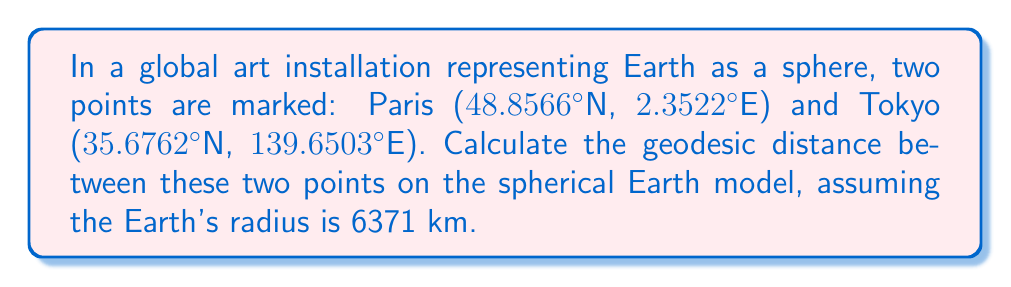Help me with this question. To calculate the geodesic distance between two points on a sphere, we use the Haversine formula:

1. Convert the latitudes and longitudes from degrees to radians:
   $$\phi_1 = 48.8566° \cdot \frac{\pi}{180} = 0.8527 \text{ rad}$$
   $$\lambda_1 = 2.3522° \cdot \frac{\pi}{180} = 0.0411 \text{ rad}$$
   $$\phi_2 = 35.6762° \cdot \frac{\pi}{180} = 0.6228 \text{ rad}$$
   $$\lambda_2 = 139.6503° \cdot \frac{\pi}{180} = 2.4372 \text{ rad}$$

2. Calculate the difference in longitude:
   $$\Delta\lambda = \lambda_2 - \lambda_1 = 2.3961 \text{ rad}$$

3. Apply the Haversine formula:
   $$a = \sin^2\left(\frac{\phi_2 - \phi_1}{2}\right) + \cos(\phi_1)\cos(\phi_2)\sin^2\left(\frac{\Delta\lambda}{2}\right)$$
   $$a = \sin^2\left(\frac{0.6228 - 0.8527}{2}\right) + \cos(0.8527)\cos(0.6228)\sin^2\left(\frac{2.3961}{2}\right)$$
   $$a = 0.4504$$

4. Calculate the central angle:
   $$c = 2 \cdot \arctan2(\sqrt{a}, \sqrt{1-a}) = 1.4679 \text{ rad}$$

5. Compute the geodesic distance:
   $$d = R \cdot c = 6371 \text{ km} \cdot 1.4679 \text{ rad} = 9356.02 \text{ km}$$

[asy]
import geometry;

size(200);
pen p = rgb(0,0,1);
draw(circle((0,0),1), p);
dot((0.866,0.5), p+2);
label("Paris", (0.866,0.5), NE);
dot((-0.707,-0.707), p+2);
label("Tokyo", (-0.707,-0.707), SW);
draw(arc((0,0), (0.866,0.5), (-0.707,-0.707)), p+1);
[/asy]
Answer: 9356.02 km 